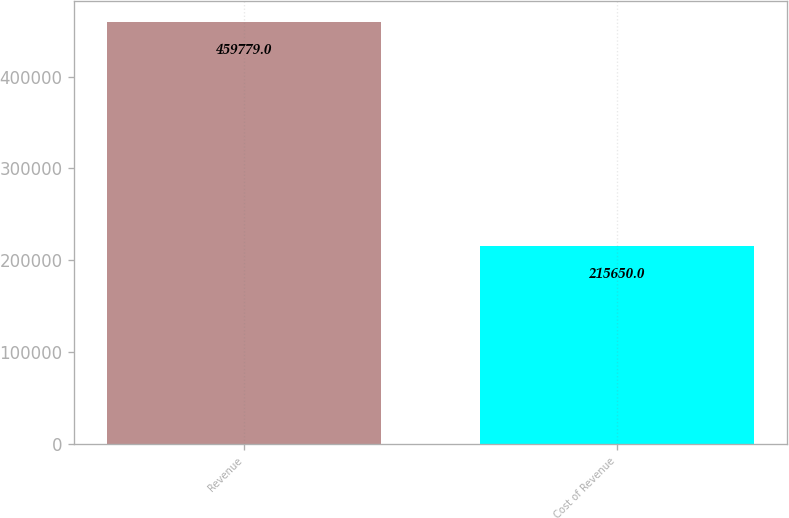<chart> <loc_0><loc_0><loc_500><loc_500><bar_chart><fcel>Revenue<fcel>Cost of Revenue<nl><fcel>459779<fcel>215650<nl></chart> 